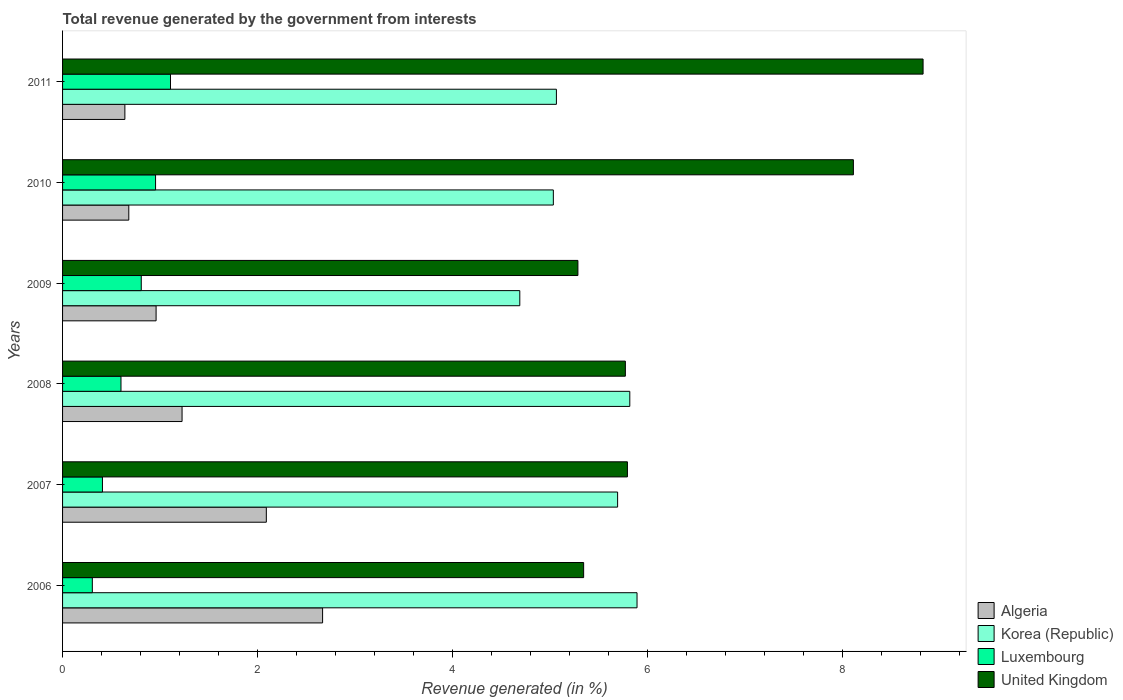How many groups of bars are there?
Keep it short and to the point. 6. Are the number of bars per tick equal to the number of legend labels?
Make the answer very short. Yes. Are the number of bars on each tick of the Y-axis equal?
Ensure brevity in your answer.  Yes. How many bars are there on the 2nd tick from the top?
Give a very brief answer. 4. In how many cases, is the number of bars for a given year not equal to the number of legend labels?
Your answer should be very brief. 0. What is the total revenue generated in Luxembourg in 2006?
Give a very brief answer. 0.31. Across all years, what is the maximum total revenue generated in United Kingdom?
Ensure brevity in your answer.  8.83. Across all years, what is the minimum total revenue generated in Luxembourg?
Ensure brevity in your answer.  0.31. In which year was the total revenue generated in United Kingdom maximum?
Keep it short and to the point. 2011. What is the total total revenue generated in United Kingdom in the graph?
Give a very brief answer. 39.16. What is the difference between the total revenue generated in Luxembourg in 2009 and that in 2010?
Make the answer very short. -0.15. What is the difference between the total revenue generated in Korea (Republic) in 2006 and the total revenue generated in United Kingdom in 2011?
Offer a terse response. -2.94. What is the average total revenue generated in Korea (Republic) per year?
Your response must be concise. 5.37. In the year 2011, what is the difference between the total revenue generated in Luxembourg and total revenue generated in Korea (Republic)?
Your answer should be compact. -3.96. What is the ratio of the total revenue generated in United Kingdom in 2008 to that in 2009?
Provide a succinct answer. 1.09. Is the difference between the total revenue generated in Luxembourg in 2007 and 2009 greater than the difference between the total revenue generated in Korea (Republic) in 2007 and 2009?
Your response must be concise. No. What is the difference between the highest and the second highest total revenue generated in Luxembourg?
Your answer should be very brief. 0.15. What is the difference between the highest and the lowest total revenue generated in Luxembourg?
Provide a succinct answer. 0.8. Is the sum of the total revenue generated in United Kingdom in 2006 and 2011 greater than the maximum total revenue generated in Algeria across all years?
Your response must be concise. Yes. Is it the case that in every year, the sum of the total revenue generated in Luxembourg and total revenue generated in United Kingdom is greater than the sum of total revenue generated in Korea (Republic) and total revenue generated in Algeria?
Your answer should be compact. No. What does the 1st bar from the bottom in 2008 represents?
Make the answer very short. Algeria. How many bars are there?
Your answer should be compact. 24. Are all the bars in the graph horizontal?
Provide a short and direct response. Yes. How many years are there in the graph?
Provide a succinct answer. 6. Are the values on the major ticks of X-axis written in scientific E-notation?
Provide a succinct answer. No. Does the graph contain any zero values?
Your response must be concise. No. Does the graph contain grids?
Keep it short and to the point. No. Where does the legend appear in the graph?
Make the answer very short. Bottom right. How many legend labels are there?
Make the answer very short. 4. How are the legend labels stacked?
Your answer should be very brief. Vertical. What is the title of the graph?
Keep it short and to the point. Total revenue generated by the government from interests. Does "Belarus" appear as one of the legend labels in the graph?
Offer a very short reply. No. What is the label or title of the X-axis?
Give a very brief answer. Revenue generated (in %). What is the Revenue generated (in %) in Algeria in 2006?
Provide a succinct answer. 2.67. What is the Revenue generated (in %) in Korea (Republic) in 2006?
Provide a succinct answer. 5.9. What is the Revenue generated (in %) of Luxembourg in 2006?
Give a very brief answer. 0.31. What is the Revenue generated (in %) in United Kingdom in 2006?
Give a very brief answer. 5.35. What is the Revenue generated (in %) in Algeria in 2007?
Offer a very short reply. 2.09. What is the Revenue generated (in %) in Korea (Republic) in 2007?
Offer a very short reply. 5.7. What is the Revenue generated (in %) in Luxembourg in 2007?
Provide a short and direct response. 0.41. What is the Revenue generated (in %) in United Kingdom in 2007?
Your answer should be compact. 5.8. What is the Revenue generated (in %) of Algeria in 2008?
Provide a short and direct response. 1.23. What is the Revenue generated (in %) of Korea (Republic) in 2008?
Your response must be concise. 5.82. What is the Revenue generated (in %) in Luxembourg in 2008?
Keep it short and to the point. 0.6. What is the Revenue generated (in %) in United Kingdom in 2008?
Ensure brevity in your answer.  5.78. What is the Revenue generated (in %) of Algeria in 2009?
Keep it short and to the point. 0.96. What is the Revenue generated (in %) in Korea (Republic) in 2009?
Your answer should be very brief. 4.69. What is the Revenue generated (in %) of Luxembourg in 2009?
Your answer should be very brief. 0.81. What is the Revenue generated (in %) of United Kingdom in 2009?
Keep it short and to the point. 5.29. What is the Revenue generated (in %) in Algeria in 2010?
Offer a very short reply. 0.68. What is the Revenue generated (in %) in Korea (Republic) in 2010?
Offer a very short reply. 5.04. What is the Revenue generated (in %) of Luxembourg in 2010?
Ensure brevity in your answer.  0.95. What is the Revenue generated (in %) of United Kingdom in 2010?
Offer a very short reply. 8.12. What is the Revenue generated (in %) in Algeria in 2011?
Provide a short and direct response. 0.64. What is the Revenue generated (in %) of Korea (Republic) in 2011?
Give a very brief answer. 5.07. What is the Revenue generated (in %) in Luxembourg in 2011?
Give a very brief answer. 1.11. What is the Revenue generated (in %) in United Kingdom in 2011?
Your response must be concise. 8.83. Across all years, what is the maximum Revenue generated (in %) of Algeria?
Ensure brevity in your answer.  2.67. Across all years, what is the maximum Revenue generated (in %) of Korea (Republic)?
Provide a short and direct response. 5.9. Across all years, what is the maximum Revenue generated (in %) in Luxembourg?
Give a very brief answer. 1.11. Across all years, what is the maximum Revenue generated (in %) in United Kingdom?
Keep it short and to the point. 8.83. Across all years, what is the minimum Revenue generated (in %) of Algeria?
Ensure brevity in your answer.  0.64. Across all years, what is the minimum Revenue generated (in %) of Korea (Republic)?
Offer a very short reply. 4.69. Across all years, what is the minimum Revenue generated (in %) of Luxembourg?
Provide a succinct answer. 0.31. Across all years, what is the minimum Revenue generated (in %) in United Kingdom?
Offer a terse response. 5.29. What is the total Revenue generated (in %) of Algeria in the graph?
Your answer should be compact. 8.27. What is the total Revenue generated (in %) in Korea (Republic) in the graph?
Give a very brief answer. 32.21. What is the total Revenue generated (in %) in Luxembourg in the graph?
Make the answer very short. 4.18. What is the total Revenue generated (in %) in United Kingdom in the graph?
Your response must be concise. 39.16. What is the difference between the Revenue generated (in %) of Algeria in 2006 and that in 2007?
Give a very brief answer. 0.58. What is the difference between the Revenue generated (in %) of Korea (Republic) in 2006 and that in 2007?
Your answer should be very brief. 0.2. What is the difference between the Revenue generated (in %) in Luxembourg in 2006 and that in 2007?
Offer a very short reply. -0.1. What is the difference between the Revenue generated (in %) of United Kingdom in 2006 and that in 2007?
Offer a very short reply. -0.45. What is the difference between the Revenue generated (in %) in Algeria in 2006 and that in 2008?
Offer a very short reply. 1.44. What is the difference between the Revenue generated (in %) in Korea (Republic) in 2006 and that in 2008?
Your answer should be compact. 0.07. What is the difference between the Revenue generated (in %) in Luxembourg in 2006 and that in 2008?
Provide a short and direct response. -0.29. What is the difference between the Revenue generated (in %) in United Kingdom in 2006 and that in 2008?
Offer a terse response. -0.43. What is the difference between the Revenue generated (in %) in Algeria in 2006 and that in 2009?
Make the answer very short. 1.71. What is the difference between the Revenue generated (in %) of Korea (Republic) in 2006 and that in 2009?
Provide a short and direct response. 1.2. What is the difference between the Revenue generated (in %) in Luxembourg in 2006 and that in 2009?
Offer a terse response. -0.5. What is the difference between the Revenue generated (in %) in United Kingdom in 2006 and that in 2009?
Provide a short and direct response. 0.06. What is the difference between the Revenue generated (in %) of Algeria in 2006 and that in 2010?
Your answer should be very brief. 1.99. What is the difference between the Revenue generated (in %) in Korea (Republic) in 2006 and that in 2010?
Provide a succinct answer. 0.86. What is the difference between the Revenue generated (in %) of Luxembourg in 2006 and that in 2010?
Your answer should be very brief. -0.65. What is the difference between the Revenue generated (in %) in United Kingdom in 2006 and that in 2010?
Offer a very short reply. -2.77. What is the difference between the Revenue generated (in %) of Algeria in 2006 and that in 2011?
Make the answer very short. 2.03. What is the difference between the Revenue generated (in %) of Korea (Republic) in 2006 and that in 2011?
Your answer should be compact. 0.83. What is the difference between the Revenue generated (in %) of Luxembourg in 2006 and that in 2011?
Ensure brevity in your answer.  -0.8. What is the difference between the Revenue generated (in %) of United Kingdom in 2006 and that in 2011?
Provide a succinct answer. -3.48. What is the difference between the Revenue generated (in %) of Algeria in 2007 and that in 2008?
Your response must be concise. 0.86. What is the difference between the Revenue generated (in %) of Korea (Republic) in 2007 and that in 2008?
Ensure brevity in your answer.  -0.12. What is the difference between the Revenue generated (in %) in Luxembourg in 2007 and that in 2008?
Ensure brevity in your answer.  -0.19. What is the difference between the Revenue generated (in %) in United Kingdom in 2007 and that in 2008?
Your answer should be very brief. 0.02. What is the difference between the Revenue generated (in %) in Algeria in 2007 and that in 2009?
Ensure brevity in your answer.  1.13. What is the difference between the Revenue generated (in %) in Luxembourg in 2007 and that in 2009?
Provide a short and direct response. -0.4. What is the difference between the Revenue generated (in %) of United Kingdom in 2007 and that in 2009?
Offer a very short reply. 0.51. What is the difference between the Revenue generated (in %) in Algeria in 2007 and that in 2010?
Give a very brief answer. 1.41. What is the difference between the Revenue generated (in %) in Korea (Republic) in 2007 and that in 2010?
Give a very brief answer. 0.66. What is the difference between the Revenue generated (in %) of Luxembourg in 2007 and that in 2010?
Provide a succinct answer. -0.55. What is the difference between the Revenue generated (in %) in United Kingdom in 2007 and that in 2010?
Your response must be concise. -2.32. What is the difference between the Revenue generated (in %) in Algeria in 2007 and that in 2011?
Provide a succinct answer. 1.45. What is the difference between the Revenue generated (in %) in Korea (Republic) in 2007 and that in 2011?
Keep it short and to the point. 0.63. What is the difference between the Revenue generated (in %) of Luxembourg in 2007 and that in 2011?
Offer a very short reply. -0.7. What is the difference between the Revenue generated (in %) in United Kingdom in 2007 and that in 2011?
Your response must be concise. -3.03. What is the difference between the Revenue generated (in %) of Algeria in 2008 and that in 2009?
Your answer should be very brief. 0.27. What is the difference between the Revenue generated (in %) in Korea (Republic) in 2008 and that in 2009?
Keep it short and to the point. 1.13. What is the difference between the Revenue generated (in %) of Luxembourg in 2008 and that in 2009?
Make the answer very short. -0.21. What is the difference between the Revenue generated (in %) in United Kingdom in 2008 and that in 2009?
Keep it short and to the point. 0.49. What is the difference between the Revenue generated (in %) in Algeria in 2008 and that in 2010?
Keep it short and to the point. 0.55. What is the difference between the Revenue generated (in %) in Korea (Republic) in 2008 and that in 2010?
Your response must be concise. 0.78. What is the difference between the Revenue generated (in %) in Luxembourg in 2008 and that in 2010?
Offer a very short reply. -0.35. What is the difference between the Revenue generated (in %) in United Kingdom in 2008 and that in 2010?
Offer a very short reply. -2.34. What is the difference between the Revenue generated (in %) in Algeria in 2008 and that in 2011?
Give a very brief answer. 0.59. What is the difference between the Revenue generated (in %) in Korea (Republic) in 2008 and that in 2011?
Give a very brief answer. 0.75. What is the difference between the Revenue generated (in %) in Luxembourg in 2008 and that in 2011?
Provide a short and direct response. -0.51. What is the difference between the Revenue generated (in %) in United Kingdom in 2008 and that in 2011?
Keep it short and to the point. -3.06. What is the difference between the Revenue generated (in %) of Algeria in 2009 and that in 2010?
Give a very brief answer. 0.28. What is the difference between the Revenue generated (in %) of Korea (Republic) in 2009 and that in 2010?
Your answer should be very brief. -0.34. What is the difference between the Revenue generated (in %) in Luxembourg in 2009 and that in 2010?
Your response must be concise. -0.15. What is the difference between the Revenue generated (in %) in United Kingdom in 2009 and that in 2010?
Make the answer very short. -2.83. What is the difference between the Revenue generated (in %) of Algeria in 2009 and that in 2011?
Ensure brevity in your answer.  0.32. What is the difference between the Revenue generated (in %) of Korea (Republic) in 2009 and that in 2011?
Your answer should be compact. -0.38. What is the difference between the Revenue generated (in %) of Luxembourg in 2009 and that in 2011?
Make the answer very short. -0.3. What is the difference between the Revenue generated (in %) in United Kingdom in 2009 and that in 2011?
Your response must be concise. -3.54. What is the difference between the Revenue generated (in %) in Algeria in 2010 and that in 2011?
Your answer should be compact. 0.04. What is the difference between the Revenue generated (in %) in Korea (Republic) in 2010 and that in 2011?
Ensure brevity in your answer.  -0.03. What is the difference between the Revenue generated (in %) of Luxembourg in 2010 and that in 2011?
Provide a succinct answer. -0.15. What is the difference between the Revenue generated (in %) of United Kingdom in 2010 and that in 2011?
Your response must be concise. -0.72. What is the difference between the Revenue generated (in %) in Algeria in 2006 and the Revenue generated (in %) in Korea (Republic) in 2007?
Give a very brief answer. -3.03. What is the difference between the Revenue generated (in %) in Algeria in 2006 and the Revenue generated (in %) in Luxembourg in 2007?
Your answer should be compact. 2.26. What is the difference between the Revenue generated (in %) of Algeria in 2006 and the Revenue generated (in %) of United Kingdom in 2007?
Your response must be concise. -3.13. What is the difference between the Revenue generated (in %) of Korea (Republic) in 2006 and the Revenue generated (in %) of Luxembourg in 2007?
Ensure brevity in your answer.  5.49. What is the difference between the Revenue generated (in %) of Korea (Republic) in 2006 and the Revenue generated (in %) of United Kingdom in 2007?
Make the answer very short. 0.1. What is the difference between the Revenue generated (in %) of Luxembourg in 2006 and the Revenue generated (in %) of United Kingdom in 2007?
Provide a short and direct response. -5.49. What is the difference between the Revenue generated (in %) in Algeria in 2006 and the Revenue generated (in %) in Korea (Republic) in 2008?
Your answer should be compact. -3.15. What is the difference between the Revenue generated (in %) of Algeria in 2006 and the Revenue generated (in %) of Luxembourg in 2008?
Ensure brevity in your answer.  2.07. What is the difference between the Revenue generated (in %) of Algeria in 2006 and the Revenue generated (in %) of United Kingdom in 2008?
Give a very brief answer. -3.11. What is the difference between the Revenue generated (in %) of Korea (Republic) in 2006 and the Revenue generated (in %) of Luxembourg in 2008?
Offer a terse response. 5.3. What is the difference between the Revenue generated (in %) of Korea (Republic) in 2006 and the Revenue generated (in %) of United Kingdom in 2008?
Make the answer very short. 0.12. What is the difference between the Revenue generated (in %) of Luxembourg in 2006 and the Revenue generated (in %) of United Kingdom in 2008?
Your answer should be very brief. -5.47. What is the difference between the Revenue generated (in %) of Algeria in 2006 and the Revenue generated (in %) of Korea (Republic) in 2009?
Offer a very short reply. -2.02. What is the difference between the Revenue generated (in %) in Algeria in 2006 and the Revenue generated (in %) in Luxembourg in 2009?
Provide a succinct answer. 1.86. What is the difference between the Revenue generated (in %) of Algeria in 2006 and the Revenue generated (in %) of United Kingdom in 2009?
Make the answer very short. -2.62. What is the difference between the Revenue generated (in %) in Korea (Republic) in 2006 and the Revenue generated (in %) in Luxembourg in 2009?
Make the answer very short. 5.09. What is the difference between the Revenue generated (in %) in Korea (Republic) in 2006 and the Revenue generated (in %) in United Kingdom in 2009?
Ensure brevity in your answer.  0.61. What is the difference between the Revenue generated (in %) in Luxembourg in 2006 and the Revenue generated (in %) in United Kingdom in 2009?
Your answer should be very brief. -4.98. What is the difference between the Revenue generated (in %) in Algeria in 2006 and the Revenue generated (in %) in Korea (Republic) in 2010?
Offer a very short reply. -2.37. What is the difference between the Revenue generated (in %) in Algeria in 2006 and the Revenue generated (in %) in Luxembourg in 2010?
Provide a succinct answer. 1.71. What is the difference between the Revenue generated (in %) in Algeria in 2006 and the Revenue generated (in %) in United Kingdom in 2010?
Make the answer very short. -5.45. What is the difference between the Revenue generated (in %) in Korea (Republic) in 2006 and the Revenue generated (in %) in Luxembourg in 2010?
Offer a very short reply. 4.94. What is the difference between the Revenue generated (in %) in Korea (Republic) in 2006 and the Revenue generated (in %) in United Kingdom in 2010?
Your response must be concise. -2.22. What is the difference between the Revenue generated (in %) of Luxembourg in 2006 and the Revenue generated (in %) of United Kingdom in 2010?
Make the answer very short. -7.81. What is the difference between the Revenue generated (in %) of Algeria in 2006 and the Revenue generated (in %) of Korea (Republic) in 2011?
Offer a very short reply. -2.4. What is the difference between the Revenue generated (in %) in Algeria in 2006 and the Revenue generated (in %) in Luxembourg in 2011?
Offer a terse response. 1.56. What is the difference between the Revenue generated (in %) of Algeria in 2006 and the Revenue generated (in %) of United Kingdom in 2011?
Your answer should be very brief. -6.16. What is the difference between the Revenue generated (in %) of Korea (Republic) in 2006 and the Revenue generated (in %) of Luxembourg in 2011?
Keep it short and to the point. 4.79. What is the difference between the Revenue generated (in %) in Korea (Republic) in 2006 and the Revenue generated (in %) in United Kingdom in 2011?
Provide a succinct answer. -2.94. What is the difference between the Revenue generated (in %) of Luxembourg in 2006 and the Revenue generated (in %) of United Kingdom in 2011?
Ensure brevity in your answer.  -8.53. What is the difference between the Revenue generated (in %) of Algeria in 2007 and the Revenue generated (in %) of Korea (Republic) in 2008?
Keep it short and to the point. -3.73. What is the difference between the Revenue generated (in %) in Algeria in 2007 and the Revenue generated (in %) in Luxembourg in 2008?
Make the answer very short. 1.49. What is the difference between the Revenue generated (in %) of Algeria in 2007 and the Revenue generated (in %) of United Kingdom in 2008?
Make the answer very short. -3.68. What is the difference between the Revenue generated (in %) in Korea (Republic) in 2007 and the Revenue generated (in %) in Luxembourg in 2008?
Ensure brevity in your answer.  5.1. What is the difference between the Revenue generated (in %) of Korea (Republic) in 2007 and the Revenue generated (in %) of United Kingdom in 2008?
Your response must be concise. -0.08. What is the difference between the Revenue generated (in %) of Luxembourg in 2007 and the Revenue generated (in %) of United Kingdom in 2008?
Ensure brevity in your answer.  -5.37. What is the difference between the Revenue generated (in %) in Algeria in 2007 and the Revenue generated (in %) in Korea (Republic) in 2009?
Offer a very short reply. -2.6. What is the difference between the Revenue generated (in %) of Algeria in 2007 and the Revenue generated (in %) of Luxembourg in 2009?
Ensure brevity in your answer.  1.28. What is the difference between the Revenue generated (in %) in Algeria in 2007 and the Revenue generated (in %) in United Kingdom in 2009?
Offer a very short reply. -3.2. What is the difference between the Revenue generated (in %) of Korea (Republic) in 2007 and the Revenue generated (in %) of Luxembourg in 2009?
Provide a succinct answer. 4.89. What is the difference between the Revenue generated (in %) of Korea (Republic) in 2007 and the Revenue generated (in %) of United Kingdom in 2009?
Your answer should be very brief. 0.41. What is the difference between the Revenue generated (in %) in Luxembourg in 2007 and the Revenue generated (in %) in United Kingdom in 2009?
Ensure brevity in your answer.  -4.88. What is the difference between the Revenue generated (in %) of Algeria in 2007 and the Revenue generated (in %) of Korea (Republic) in 2010?
Offer a terse response. -2.95. What is the difference between the Revenue generated (in %) of Algeria in 2007 and the Revenue generated (in %) of Luxembourg in 2010?
Ensure brevity in your answer.  1.14. What is the difference between the Revenue generated (in %) of Algeria in 2007 and the Revenue generated (in %) of United Kingdom in 2010?
Give a very brief answer. -6.03. What is the difference between the Revenue generated (in %) in Korea (Republic) in 2007 and the Revenue generated (in %) in Luxembourg in 2010?
Ensure brevity in your answer.  4.74. What is the difference between the Revenue generated (in %) of Korea (Republic) in 2007 and the Revenue generated (in %) of United Kingdom in 2010?
Ensure brevity in your answer.  -2.42. What is the difference between the Revenue generated (in %) of Luxembourg in 2007 and the Revenue generated (in %) of United Kingdom in 2010?
Offer a terse response. -7.71. What is the difference between the Revenue generated (in %) in Algeria in 2007 and the Revenue generated (in %) in Korea (Republic) in 2011?
Keep it short and to the point. -2.98. What is the difference between the Revenue generated (in %) of Algeria in 2007 and the Revenue generated (in %) of Luxembourg in 2011?
Your answer should be compact. 0.98. What is the difference between the Revenue generated (in %) in Algeria in 2007 and the Revenue generated (in %) in United Kingdom in 2011?
Ensure brevity in your answer.  -6.74. What is the difference between the Revenue generated (in %) in Korea (Republic) in 2007 and the Revenue generated (in %) in Luxembourg in 2011?
Offer a very short reply. 4.59. What is the difference between the Revenue generated (in %) of Korea (Republic) in 2007 and the Revenue generated (in %) of United Kingdom in 2011?
Your response must be concise. -3.13. What is the difference between the Revenue generated (in %) of Luxembourg in 2007 and the Revenue generated (in %) of United Kingdom in 2011?
Offer a terse response. -8.42. What is the difference between the Revenue generated (in %) of Algeria in 2008 and the Revenue generated (in %) of Korea (Republic) in 2009?
Keep it short and to the point. -3.47. What is the difference between the Revenue generated (in %) of Algeria in 2008 and the Revenue generated (in %) of Luxembourg in 2009?
Provide a short and direct response. 0.42. What is the difference between the Revenue generated (in %) of Algeria in 2008 and the Revenue generated (in %) of United Kingdom in 2009?
Your answer should be compact. -4.06. What is the difference between the Revenue generated (in %) of Korea (Republic) in 2008 and the Revenue generated (in %) of Luxembourg in 2009?
Your answer should be very brief. 5.01. What is the difference between the Revenue generated (in %) in Korea (Republic) in 2008 and the Revenue generated (in %) in United Kingdom in 2009?
Ensure brevity in your answer.  0.53. What is the difference between the Revenue generated (in %) of Luxembourg in 2008 and the Revenue generated (in %) of United Kingdom in 2009?
Your answer should be compact. -4.69. What is the difference between the Revenue generated (in %) in Algeria in 2008 and the Revenue generated (in %) in Korea (Republic) in 2010?
Make the answer very short. -3.81. What is the difference between the Revenue generated (in %) of Algeria in 2008 and the Revenue generated (in %) of Luxembourg in 2010?
Provide a succinct answer. 0.27. What is the difference between the Revenue generated (in %) in Algeria in 2008 and the Revenue generated (in %) in United Kingdom in 2010?
Ensure brevity in your answer.  -6.89. What is the difference between the Revenue generated (in %) in Korea (Republic) in 2008 and the Revenue generated (in %) in Luxembourg in 2010?
Provide a succinct answer. 4.87. What is the difference between the Revenue generated (in %) of Korea (Republic) in 2008 and the Revenue generated (in %) of United Kingdom in 2010?
Keep it short and to the point. -2.29. What is the difference between the Revenue generated (in %) of Luxembourg in 2008 and the Revenue generated (in %) of United Kingdom in 2010?
Keep it short and to the point. -7.52. What is the difference between the Revenue generated (in %) of Algeria in 2008 and the Revenue generated (in %) of Korea (Republic) in 2011?
Offer a terse response. -3.84. What is the difference between the Revenue generated (in %) of Algeria in 2008 and the Revenue generated (in %) of Luxembourg in 2011?
Provide a succinct answer. 0.12. What is the difference between the Revenue generated (in %) in Algeria in 2008 and the Revenue generated (in %) in United Kingdom in 2011?
Ensure brevity in your answer.  -7.61. What is the difference between the Revenue generated (in %) in Korea (Republic) in 2008 and the Revenue generated (in %) in Luxembourg in 2011?
Offer a terse response. 4.71. What is the difference between the Revenue generated (in %) of Korea (Republic) in 2008 and the Revenue generated (in %) of United Kingdom in 2011?
Provide a short and direct response. -3.01. What is the difference between the Revenue generated (in %) in Luxembourg in 2008 and the Revenue generated (in %) in United Kingdom in 2011?
Keep it short and to the point. -8.23. What is the difference between the Revenue generated (in %) in Algeria in 2009 and the Revenue generated (in %) in Korea (Republic) in 2010?
Ensure brevity in your answer.  -4.08. What is the difference between the Revenue generated (in %) in Algeria in 2009 and the Revenue generated (in %) in Luxembourg in 2010?
Your response must be concise. 0.01. What is the difference between the Revenue generated (in %) of Algeria in 2009 and the Revenue generated (in %) of United Kingdom in 2010?
Offer a very short reply. -7.16. What is the difference between the Revenue generated (in %) in Korea (Republic) in 2009 and the Revenue generated (in %) in Luxembourg in 2010?
Your answer should be compact. 3.74. What is the difference between the Revenue generated (in %) in Korea (Republic) in 2009 and the Revenue generated (in %) in United Kingdom in 2010?
Provide a short and direct response. -3.42. What is the difference between the Revenue generated (in %) in Luxembourg in 2009 and the Revenue generated (in %) in United Kingdom in 2010?
Keep it short and to the point. -7.31. What is the difference between the Revenue generated (in %) of Algeria in 2009 and the Revenue generated (in %) of Korea (Republic) in 2011?
Your response must be concise. -4.11. What is the difference between the Revenue generated (in %) in Algeria in 2009 and the Revenue generated (in %) in Luxembourg in 2011?
Offer a terse response. -0.15. What is the difference between the Revenue generated (in %) of Algeria in 2009 and the Revenue generated (in %) of United Kingdom in 2011?
Provide a succinct answer. -7.87. What is the difference between the Revenue generated (in %) of Korea (Republic) in 2009 and the Revenue generated (in %) of Luxembourg in 2011?
Your answer should be very brief. 3.58. What is the difference between the Revenue generated (in %) of Korea (Republic) in 2009 and the Revenue generated (in %) of United Kingdom in 2011?
Your answer should be compact. -4.14. What is the difference between the Revenue generated (in %) of Luxembourg in 2009 and the Revenue generated (in %) of United Kingdom in 2011?
Keep it short and to the point. -8.02. What is the difference between the Revenue generated (in %) of Algeria in 2010 and the Revenue generated (in %) of Korea (Republic) in 2011?
Offer a very short reply. -4.39. What is the difference between the Revenue generated (in %) in Algeria in 2010 and the Revenue generated (in %) in Luxembourg in 2011?
Make the answer very short. -0.43. What is the difference between the Revenue generated (in %) in Algeria in 2010 and the Revenue generated (in %) in United Kingdom in 2011?
Your answer should be very brief. -8.15. What is the difference between the Revenue generated (in %) of Korea (Republic) in 2010 and the Revenue generated (in %) of Luxembourg in 2011?
Offer a terse response. 3.93. What is the difference between the Revenue generated (in %) of Korea (Republic) in 2010 and the Revenue generated (in %) of United Kingdom in 2011?
Make the answer very short. -3.79. What is the difference between the Revenue generated (in %) in Luxembourg in 2010 and the Revenue generated (in %) in United Kingdom in 2011?
Provide a short and direct response. -7.88. What is the average Revenue generated (in %) in Algeria per year?
Your answer should be compact. 1.38. What is the average Revenue generated (in %) in Korea (Republic) per year?
Provide a succinct answer. 5.37. What is the average Revenue generated (in %) in Luxembourg per year?
Make the answer very short. 0.7. What is the average Revenue generated (in %) of United Kingdom per year?
Your response must be concise. 6.53. In the year 2006, what is the difference between the Revenue generated (in %) in Algeria and Revenue generated (in %) in Korea (Republic)?
Your answer should be very brief. -3.23. In the year 2006, what is the difference between the Revenue generated (in %) of Algeria and Revenue generated (in %) of Luxembourg?
Ensure brevity in your answer.  2.36. In the year 2006, what is the difference between the Revenue generated (in %) in Algeria and Revenue generated (in %) in United Kingdom?
Provide a short and direct response. -2.68. In the year 2006, what is the difference between the Revenue generated (in %) of Korea (Republic) and Revenue generated (in %) of Luxembourg?
Your response must be concise. 5.59. In the year 2006, what is the difference between the Revenue generated (in %) in Korea (Republic) and Revenue generated (in %) in United Kingdom?
Your answer should be compact. 0.55. In the year 2006, what is the difference between the Revenue generated (in %) in Luxembourg and Revenue generated (in %) in United Kingdom?
Your answer should be very brief. -5.04. In the year 2007, what is the difference between the Revenue generated (in %) in Algeria and Revenue generated (in %) in Korea (Republic)?
Ensure brevity in your answer.  -3.61. In the year 2007, what is the difference between the Revenue generated (in %) in Algeria and Revenue generated (in %) in Luxembourg?
Offer a terse response. 1.68. In the year 2007, what is the difference between the Revenue generated (in %) of Algeria and Revenue generated (in %) of United Kingdom?
Your answer should be compact. -3.71. In the year 2007, what is the difference between the Revenue generated (in %) in Korea (Republic) and Revenue generated (in %) in Luxembourg?
Make the answer very short. 5.29. In the year 2007, what is the difference between the Revenue generated (in %) in Korea (Republic) and Revenue generated (in %) in United Kingdom?
Offer a terse response. -0.1. In the year 2007, what is the difference between the Revenue generated (in %) in Luxembourg and Revenue generated (in %) in United Kingdom?
Offer a terse response. -5.39. In the year 2008, what is the difference between the Revenue generated (in %) in Algeria and Revenue generated (in %) in Korea (Republic)?
Offer a very short reply. -4.59. In the year 2008, what is the difference between the Revenue generated (in %) in Algeria and Revenue generated (in %) in Luxembourg?
Make the answer very short. 0.63. In the year 2008, what is the difference between the Revenue generated (in %) in Algeria and Revenue generated (in %) in United Kingdom?
Make the answer very short. -4.55. In the year 2008, what is the difference between the Revenue generated (in %) in Korea (Republic) and Revenue generated (in %) in Luxembourg?
Offer a terse response. 5.22. In the year 2008, what is the difference between the Revenue generated (in %) of Korea (Republic) and Revenue generated (in %) of United Kingdom?
Offer a terse response. 0.05. In the year 2008, what is the difference between the Revenue generated (in %) in Luxembourg and Revenue generated (in %) in United Kingdom?
Offer a terse response. -5.18. In the year 2009, what is the difference between the Revenue generated (in %) in Algeria and Revenue generated (in %) in Korea (Republic)?
Ensure brevity in your answer.  -3.73. In the year 2009, what is the difference between the Revenue generated (in %) in Algeria and Revenue generated (in %) in Luxembourg?
Give a very brief answer. 0.15. In the year 2009, what is the difference between the Revenue generated (in %) of Algeria and Revenue generated (in %) of United Kingdom?
Offer a terse response. -4.33. In the year 2009, what is the difference between the Revenue generated (in %) in Korea (Republic) and Revenue generated (in %) in Luxembourg?
Make the answer very short. 3.88. In the year 2009, what is the difference between the Revenue generated (in %) of Korea (Republic) and Revenue generated (in %) of United Kingdom?
Your answer should be very brief. -0.6. In the year 2009, what is the difference between the Revenue generated (in %) in Luxembourg and Revenue generated (in %) in United Kingdom?
Make the answer very short. -4.48. In the year 2010, what is the difference between the Revenue generated (in %) of Algeria and Revenue generated (in %) of Korea (Republic)?
Offer a terse response. -4.36. In the year 2010, what is the difference between the Revenue generated (in %) of Algeria and Revenue generated (in %) of Luxembourg?
Ensure brevity in your answer.  -0.27. In the year 2010, what is the difference between the Revenue generated (in %) of Algeria and Revenue generated (in %) of United Kingdom?
Your response must be concise. -7.44. In the year 2010, what is the difference between the Revenue generated (in %) in Korea (Republic) and Revenue generated (in %) in Luxembourg?
Give a very brief answer. 4.08. In the year 2010, what is the difference between the Revenue generated (in %) in Korea (Republic) and Revenue generated (in %) in United Kingdom?
Provide a succinct answer. -3.08. In the year 2010, what is the difference between the Revenue generated (in %) of Luxembourg and Revenue generated (in %) of United Kingdom?
Keep it short and to the point. -7.16. In the year 2011, what is the difference between the Revenue generated (in %) of Algeria and Revenue generated (in %) of Korea (Republic)?
Provide a succinct answer. -4.43. In the year 2011, what is the difference between the Revenue generated (in %) of Algeria and Revenue generated (in %) of Luxembourg?
Keep it short and to the point. -0.47. In the year 2011, what is the difference between the Revenue generated (in %) of Algeria and Revenue generated (in %) of United Kingdom?
Give a very brief answer. -8.19. In the year 2011, what is the difference between the Revenue generated (in %) in Korea (Republic) and Revenue generated (in %) in Luxembourg?
Your answer should be very brief. 3.96. In the year 2011, what is the difference between the Revenue generated (in %) of Korea (Republic) and Revenue generated (in %) of United Kingdom?
Keep it short and to the point. -3.76. In the year 2011, what is the difference between the Revenue generated (in %) of Luxembourg and Revenue generated (in %) of United Kingdom?
Your response must be concise. -7.72. What is the ratio of the Revenue generated (in %) in Algeria in 2006 to that in 2007?
Make the answer very short. 1.28. What is the ratio of the Revenue generated (in %) in Korea (Republic) in 2006 to that in 2007?
Give a very brief answer. 1.03. What is the ratio of the Revenue generated (in %) of Luxembourg in 2006 to that in 2007?
Make the answer very short. 0.75. What is the ratio of the Revenue generated (in %) in United Kingdom in 2006 to that in 2007?
Offer a very short reply. 0.92. What is the ratio of the Revenue generated (in %) in Algeria in 2006 to that in 2008?
Your answer should be compact. 2.18. What is the ratio of the Revenue generated (in %) in Korea (Republic) in 2006 to that in 2008?
Your answer should be very brief. 1.01. What is the ratio of the Revenue generated (in %) of Luxembourg in 2006 to that in 2008?
Give a very brief answer. 0.51. What is the ratio of the Revenue generated (in %) of United Kingdom in 2006 to that in 2008?
Ensure brevity in your answer.  0.93. What is the ratio of the Revenue generated (in %) of Algeria in 2006 to that in 2009?
Ensure brevity in your answer.  2.78. What is the ratio of the Revenue generated (in %) in Korea (Republic) in 2006 to that in 2009?
Make the answer very short. 1.26. What is the ratio of the Revenue generated (in %) in Luxembourg in 2006 to that in 2009?
Make the answer very short. 0.38. What is the ratio of the Revenue generated (in %) of United Kingdom in 2006 to that in 2009?
Offer a very short reply. 1.01. What is the ratio of the Revenue generated (in %) of Algeria in 2006 to that in 2010?
Offer a very short reply. 3.93. What is the ratio of the Revenue generated (in %) of Korea (Republic) in 2006 to that in 2010?
Give a very brief answer. 1.17. What is the ratio of the Revenue generated (in %) in Luxembourg in 2006 to that in 2010?
Provide a succinct answer. 0.32. What is the ratio of the Revenue generated (in %) of United Kingdom in 2006 to that in 2010?
Make the answer very short. 0.66. What is the ratio of the Revenue generated (in %) in Algeria in 2006 to that in 2011?
Offer a terse response. 4.17. What is the ratio of the Revenue generated (in %) in Korea (Republic) in 2006 to that in 2011?
Offer a very short reply. 1.16. What is the ratio of the Revenue generated (in %) in Luxembourg in 2006 to that in 2011?
Provide a short and direct response. 0.28. What is the ratio of the Revenue generated (in %) of United Kingdom in 2006 to that in 2011?
Your response must be concise. 0.61. What is the ratio of the Revenue generated (in %) in Algeria in 2007 to that in 2008?
Ensure brevity in your answer.  1.71. What is the ratio of the Revenue generated (in %) of Korea (Republic) in 2007 to that in 2008?
Your answer should be very brief. 0.98. What is the ratio of the Revenue generated (in %) of Luxembourg in 2007 to that in 2008?
Offer a terse response. 0.68. What is the ratio of the Revenue generated (in %) in Algeria in 2007 to that in 2009?
Give a very brief answer. 2.18. What is the ratio of the Revenue generated (in %) of Korea (Republic) in 2007 to that in 2009?
Offer a terse response. 1.21. What is the ratio of the Revenue generated (in %) of Luxembourg in 2007 to that in 2009?
Provide a succinct answer. 0.51. What is the ratio of the Revenue generated (in %) in United Kingdom in 2007 to that in 2009?
Offer a terse response. 1.1. What is the ratio of the Revenue generated (in %) in Algeria in 2007 to that in 2010?
Offer a terse response. 3.08. What is the ratio of the Revenue generated (in %) of Korea (Republic) in 2007 to that in 2010?
Provide a short and direct response. 1.13. What is the ratio of the Revenue generated (in %) of Luxembourg in 2007 to that in 2010?
Your response must be concise. 0.43. What is the ratio of the Revenue generated (in %) of Algeria in 2007 to that in 2011?
Provide a short and direct response. 3.27. What is the ratio of the Revenue generated (in %) in Korea (Republic) in 2007 to that in 2011?
Give a very brief answer. 1.12. What is the ratio of the Revenue generated (in %) of Luxembourg in 2007 to that in 2011?
Give a very brief answer. 0.37. What is the ratio of the Revenue generated (in %) of United Kingdom in 2007 to that in 2011?
Offer a very short reply. 0.66. What is the ratio of the Revenue generated (in %) in Algeria in 2008 to that in 2009?
Give a very brief answer. 1.28. What is the ratio of the Revenue generated (in %) in Korea (Republic) in 2008 to that in 2009?
Keep it short and to the point. 1.24. What is the ratio of the Revenue generated (in %) of Luxembourg in 2008 to that in 2009?
Your answer should be compact. 0.74. What is the ratio of the Revenue generated (in %) of United Kingdom in 2008 to that in 2009?
Offer a terse response. 1.09. What is the ratio of the Revenue generated (in %) in Algeria in 2008 to that in 2010?
Your answer should be compact. 1.8. What is the ratio of the Revenue generated (in %) in Korea (Republic) in 2008 to that in 2010?
Your answer should be compact. 1.16. What is the ratio of the Revenue generated (in %) in Luxembourg in 2008 to that in 2010?
Ensure brevity in your answer.  0.63. What is the ratio of the Revenue generated (in %) of United Kingdom in 2008 to that in 2010?
Ensure brevity in your answer.  0.71. What is the ratio of the Revenue generated (in %) of Algeria in 2008 to that in 2011?
Provide a succinct answer. 1.92. What is the ratio of the Revenue generated (in %) in Korea (Republic) in 2008 to that in 2011?
Your response must be concise. 1.15. What is the ratio of the Revenue generated (in %) in Luxembourg in 2008 to that in 2011?
Your response must be concise. 0.54. What is the ratio of the Revenue generated (in %) of United Kingdom in 2008 to that in 2011?
Provide a short and direct response. 0.65. What is the ratio of the Revenue generated (in %) in Algeria in 2009 to that in 2010?
Provide a succinct answer. 1.41. What is the ratio of the Revenue generated (in %) of Korea (Republic) in 2009 to that in 2010?
Make the answer very short. 0.93. What is the ratio of the Revenue generated (in %) of Luxembourg in 2009 to that in 2010?
Make the answer very short. 0.85. What is the ratio of the Revenue generated (in %) of United Kingdom in 2009 to that in 2010?
Your answer should be compact. 0.65. What is the ratio of the Revenue generated (in %) of Algeria in 2009 to that in 2011?
Your answer should be very brief. 1.5. What is the ratio of the Revenue generated (in %) of Korea (Republic) in 2009 to that in 2011?
Make the answer very short. 0.93. What is the ratio of the Revenue generated (in %) of Luxembourg in 2009 to that in 2011?
Your response must be concise. 0.73. What is the ratio of the Revenue generated (in %) in United Kingdom in 2009 to that in 2011?
Make the answer very short. 0.6. What is the ratio of the Revenue generated (in %) of Algeria in 2010 to that in 2011?
Give a very brief answer. 1.06. What is the ratio of the Revenue generated (in %) of Luxembourg in 2010 to that in 2011?
Give a very brief answer. 0.86. What is the ratio of the Revenue generated (in %) of United Kingdom in 2010 to that in 2011?
Offer a very short reply. 0.92. What is the difference between the highest and the second highest Revenue generated (in %) in Algeria?
Make the answer very short. 0.58. What is the difference between the highest and the second highest Revenue generated (in %) in Korea (Republic)?
Your answer should be compact. 0.07. What is the difference between the highest and the second highest Revenue generated (in %) of Luxembourg?
Keep it short and to the point. 0.15. What is the difference between the highest and the second highest Revenue generated (in %) of United Kingdom?
Give a very brief answer. 0.72. What is the difference between the highest and the lowest Revenue generated (in %) of Algeria?
Offer a terse response. 2.03. What is the difference between the highest and the lowest Revenue generated (in %) of Korea (Republic)?
Offer a very short reply. 1.2. What is the difference between the highest and the lowest Revenue generated (in %) in Luxembourg?
Offer a very short reply. 0.8. What is the difference between the highest and the lowest Revenue generated (in %) of United Kingdom?
Your answer should be very brief. 3.54. 